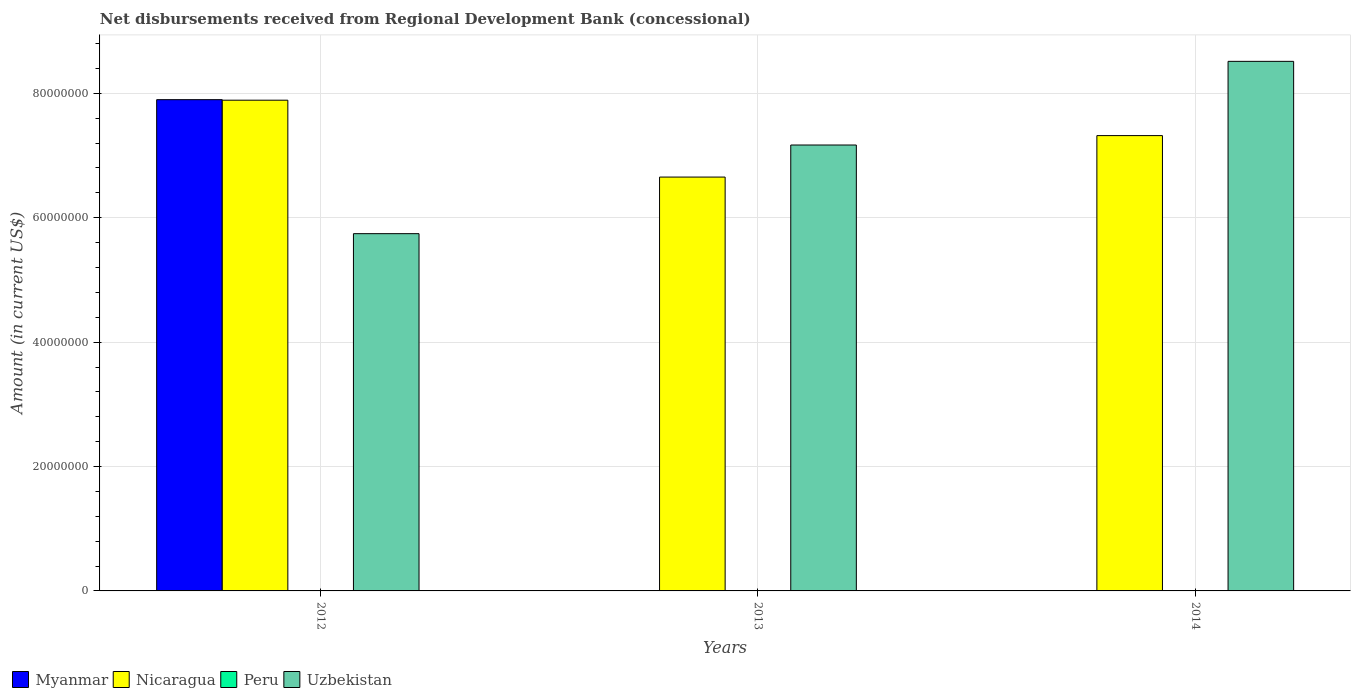How many bars are there on the 3rd tick from the left?
Provide a short and direct response. 2. What is the label of the 2nd group of bars from the left?
Give a very brief answer. 2013. What is the amount of disbursements received from Regional Development Bank in Peru in 2014?
Offer a very short reply. 0. Across all years, what is the maximum amount of disbursements received from Regional Development Bank in Myanmar?
Keep it short and to the point. 7.90e+07. Across all years, what is the minimum amount of disbursements received from Regional Development Bank in Peru?
Your response must be concise. 0. In which year was the amount of disbursements received from Regional Development Bank in Myanmar maximum?
Provide a short and direct response. 2012. What is the total amount of disbursements received from Regional Development Bank in Uzbekistan in the graph?
Offer a very short reply. 2.14e+08. What is the difference between the amount of disbursements received from Regional Development Bank in Nicaragua in 2013 and that in 2014?
Offer a terse response. -6.67e+06. What is the difference between the amount of disbursements received from Regional Development Bank in Uzbekistan in 2012 and the amount of disbursements received from Regional Development Bank in Nicaragua in 2013?
Provide a short and direct response. -9.10e+06. In the year 2013, what is the difference between the amount of disbursements received from Regional Development Bank in Nicaragua and amount of disbursements received from Regional Development Bank in Uzbekistan?
Provide a succinct answer. -5.16e+06. What is the ratio of the amount of disbursements received from Regional Development Bank in Nicaragua in 2013 to that in 2014?
Keep it short and to the point. 0.91. What is the difference between the highest and the second highest amount of disbursements received from Regional Development Bank in Nicaragua?
Ensure brevity in your answer.  5.69e+06. What is the difference between the highest and the lowest amount of disbursements received from Regional Development Bank in Nicaragua?
Ensure brevity in your answer.  1.24e+07. In how many years, is the amount of disbursements received from Regional Development Bank in Peru greater than the average amount of disbursements received from Regional Development Bank in Peru taken over all years?
Your answer should be compact. 0. Is the sum of the amount of disbursements received from Regional Development Bank in Uzbekistan in 2013 and 2014 greater than the maximum amount of disbursements received from Regional Development Bank in Peru across all years?
Ensure brevity in your answer.  Yes. Is it the case that in every year, the sum of the amount of disbursements received from Regional Development Bank in Nicaragua and amount of disbursements received from Regional Development Bank in Peru is greater than the sum of amount of disbursements received from Regional Development Bank in Myanmar and amount of disbursements received from Regional Development Bank in Uzbekistan?
Provide a succinct answer. No. How many bars are there?
Ensure brevity in your answer.  7. How many years are there in the graph?
Your response must be concise. 3. What is the difference between two consecutive major ticks on the Y-axis?
Your response must be concise. 2.00e+07. Does the graph contain any zero values?
Your answer should be very brief. Yes. Does the graph contain grids?
Keep it short and to the point. Yes. How many legend labels are there?
Your answer should be compact. 4. What is the title of the graph?
Keep it short and to the point. Net disbursements received from Regional Development Bank (concessional). What is the Amount (in current US$) in Myanmar in 2012?
Ensure brevity in your answer.  7.90e+07. What is the Amount (in current US$) of Nicaragua in 2012?
Provide a succinct answer. 7.89e+07. What is the Amount (in current US$) in Peru in 2012?
Your answer should be compact. 0. What is the Amount (in current US$) of Uzbekistan in 2012?
Your response must be concise. 5.74e+07. What is the Amount (in current US$) of Nicaragua in 2013?
Provide a succinct answer. 6.65e+07. What is the Amount (in current US$) in Peru in 2013?
Your response must be concise. 0. What is the Amount (in current US$) in Uzbekistan in 2013?
Ensure brevity in your answer.  7.17e+07. What is the Amount (in current US$) in Myanmar in 2014?
Offer a terse response. 0. What is the Amount (in current US$) of Nicaragua in 2014?
Make the answer very short. 7.32e+07. What is the Amount (in current US$) of Uzbekistan in 2014?
Provide a short and direct response. 8.51e+07. Across all years, what is the maximum Amount (in current US$) in Myanmar?
Ensure brevity in your answer.  7.90e+07. Across all years, what is the maximum Amount (in current US$) of Nicaragua?
Ensure brevity in your answer.  7.89e+07. Across all years, what is the maximum Amount (in current US$) of Uzbekistan?
Offer a very short reply. 8.51e+07. Across all years, what is the minimum Amount (in current US$) of Myanmar?
Give a very brief answer. 0. Across all years, what is the minimum Amount (in current US$) of Nicaragua?
Ensure brevity in your answer.  6.65e+07. Across all years, what is the minimum Amount (in current US$) of Uzbekistan?
Offer a very short reply. 5.74e+07. What is the total Amount (in current US$) in Myanmar in the graph?
Your response must be concise. 7.90e+07. What is the total Amount (in current US$) of Nicaragua in the graph?
Keep it short and to the point. 2.19e+08. What is the total Amount (in current US$) in Peru in the graph?
Provide a succinct answer. 0. What is the total Amount (in current US$) in Uzbekistan in the graph?
Keep it short and to the point. 2.14e+08. What is the difference between the Amount (in current US$) in Nicaragua in 2012 and that in 2013?
Provide a succinct answer. 1.24e+07. What is the difference between the Amount (in current US$) in Uzbekistan in 2012 and that in 2013?
Provide a succinct answer. -1.43e+07. What is the difference between the Amount (in current US$) of Nicaragua in 2012 and that in 2014?
Offer a terse response. 5.69e+06. What is the difference between the Amount (in current US$) in Uzbekistan in 2012 and that in 2014?
Make the answer very short. -2.77e+07. What is the difference between the Amount (in current US$) of Nicaragua in 2013 and that in 2014?
Provide a short and direct response. -6.67e+06. What is the difference between the Amount (in current US$) in Uzbekistan in 2013 and that in 2014?
Provide a succinct answer. -1.34e+07. What is the difference between the Amount (in current US$) in Myanmar in 2012 and the Amount (in current US$) in Nicaragua in 2013?
Your answer should be very brief. 1.24e+07. What is the difference between the Amount (in current US$) in Myanmar in 2012 and the Amount (in current US$) in Uzbekistan in 2013?
Give a very brief answer. 7.29e+06. What is the difference between the Amount (in current US$) in Nicaragua in 2012 and the Amount (in current US$) in Uzbekistan in 2013?
Offer a terse response. 7.20e+06. What is the difference between the Amount (in current US$) in Myanmar in 2012 and the Amount (in current US$) in Nicaragua in 2014?
Give a very brief answer. 5.78e+06. What is the difference between the Amount (in current US$) in Myanmar in 2012 and the Amount (in current US$) in Uzbekistan in 2014?
Give a very brief answer. -6.16e+06. What is the difference between the Amount (in current US$) of Nicaragua in 2012 and the Amount (in current US$) of Uzbekistan in 2014?
Your answer should be very brief. -6.25e+06. What is the difference between the Amount (in current US$) in Nicaragua in 2013 and the Amount (in current US$) in Uzbekistan in 2014?
Offer a terse response. -1.86e+07. What is the average Amount (in current US$) in Myanmar per year?
Your response must be concise. 2.63e+07. What is the average Amount (in current US$) of Nicaragua per year?
Offer a very short reply. 7.29e+07. What is the average Amount (in current US$) in Peru per year?
Ensure brevity in your answer.  0. What is the average Amount (in current US$) of Uzbekistan per year?
Your answer should be very brief. 7.14e+07. In the year 2012, what is the difference between the Amount (in current US$) of Myanmar and Amount (in current US$) of Nicaragua?
Your response must be concise. 8.60e+04. In the year 2012, what is the difference between the Amount (in current US$) in Myanmar and Amount (in current US$) in Uzbekistan?
Offer a terse response. 2.15e+07. In the year 2012, what is the difference between the Amount (in current US$) of Nicaragua and Amount (in current US$) of Uzbekistan?
Keep it short and to the point. 2.15e+07. In the year 2013, what is the difference between the Amount (in current US$) of Nicaragua and Amount (in current US$) of Uzbekistan?
Give a very brief answer. -5.16e+06. In the year 2014, what is the difference between the Amount (in current US$) of Nicaragua and Amount (in current US$) of Uzbekistan?
Your answer should be compact. -1.19e+07. What is the ratio of the Amount (in current US$) in Nicaragua in 2012 to that in 2013?
Provide a short and direct response. 1.19. What is the ratio of the Amount (in current US$) in Uzbekistan in 2012 to that in 2013?
Provide a short and direct response. 0.8. What is the ratio of the Amount (in current US$) of Nicaragua in 2012 to that in 2014?
Your answer should be compact. 1.08. What is the ratio of the Amount (in current US$) in Uzbekistan in 2012 to that in 2014?
Your response must be concise. 0.67. What is the ratio of the Amount (in current US$) in Nicaragua in 2013 to that in 2014?
Offer a very short reply. 0.91. What is the ratio of the Amount (in current US$) in Uzbekistan in 2013 to that in 2014?
Make the answer very short. 0.84. What is the difference between the highest and the second highest Amount (in current US$) of Nicaragua?
Your answer should be compact. 5.69e+06. What is the difference between the highest and the second highest Amount (in current US$) of Uzbekistan?
Your response must be concise. 1.34e+07. What is the difference between the highest and the lowest Amount (in current US$) in Myanmar?
Your answer should be very brief. 7.90e+07. What is the difference between the highest and the lowest Amount (in current US$) in Nicaragua?
Your response must be concise. 1.24e+07. What is the difference between the highest and the lowest Amount (in current US$) of Uzbekistan?
Offer a terse response. 2.77e+07. 